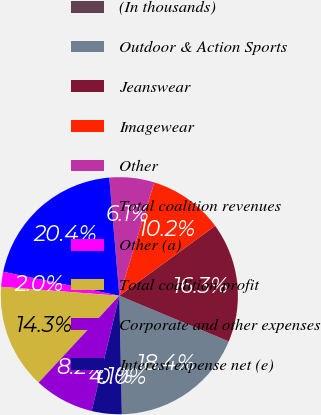Convert chart to OTSL. <chart><loc_0><loc_0><loc_500><loc_500><pie_chart><fcel>(In thousands)<fcel>Outdoor & Action Sports<fcel>Jeanswear<fcel>Imagewear<fcel>Other<fcel>Total coalition revenues<fcel>Other (a)<fcel>Total coalition profit<fcel>Corporate and other expenses<fcel>Interest expense net (e)<nl><fcel>0.0%<fcel>18.36%<fcel>16.32%<fcel>10.2%<fcel>6.12%<fcel>20.4%<fcel>2.04%<fcel>14.28%<fcel>8.16%<fcel>4.08%<nl></chart> 